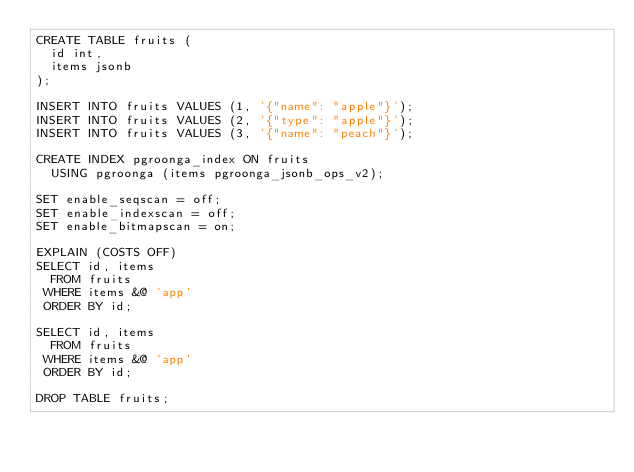<code> <loc_0><loc_0><loc_500><loc_500><_SQL_>CREATE TABLE fruits (
  id int,
  items jsonb
);

INSERT INTO fruits VALUES (1, '{"name": "apple"}');
INSERT INTO fruits VALUES (2, '{"type": "apple"}');
INSERT INTO fruits VALUES (3, '{"name": "peach"}');

CREATE INDEX pgroonga_index ON fruits
  USING pgroonga (items pgroonga_jsonb_ops_v2);

SET enable_seqscan = off;
SET enable_indexscan = off;
SET enable_bitmapscan = on;

EXPLAIN (COSTS OFF)
SELECT id, items
  FROM fruits
 WHERE items &@ 'app'
 ORDER BY id;

SELECT id, items
  FROM fruits
 WHERE items &@ 'app'
 ORDER BY id;

DROP TABLE fruits;
</code> 